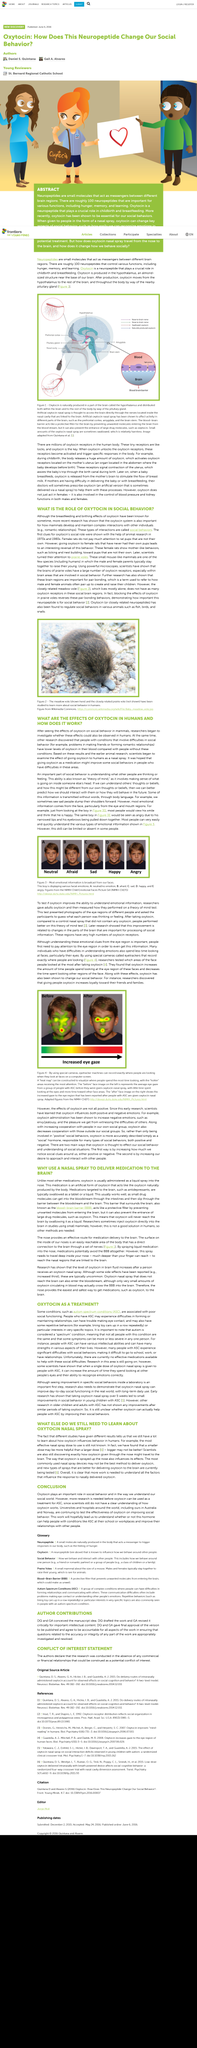Identify some key points in this picture. Oxytocin regulates social behaviors in various animals, as it has been demonstrated to do so in multiple species. Oxytocin is produced in the hypothalamus, which is located in the brain. The use of oxytocin is employed by researchers to determine if it enhances the ability to comprehend emotional information. Female rats do not typically pay much attention to rat pups that are not their own. Artificial oxytocin nasal spray is found to induce brain activity in specific regions of the brain, including the prefrontal cortex, amygdala, and the brain stem. 